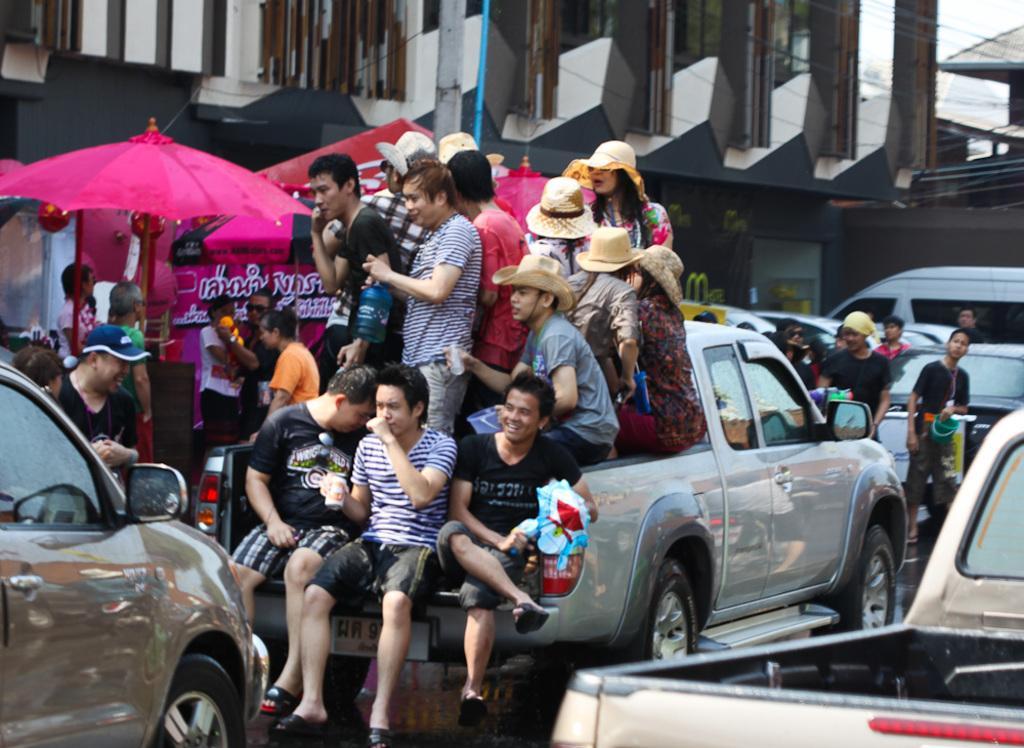Please provide a concise description of this image. This picture shows a building and a umbrella and we see few people are standing on a mini van and few people are seated on it and we see few cars along with we see few people are standing on the road. 